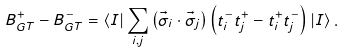<formula> <loc_0><loc_0><loc_500><loc_500>B _ { G T } ^ { + } - B _ { G T } ^ { - } = \left \langle I \right | \sum _ { i , j } \left ( \vec { \sigma } _ { i } \cdot \vec { \sigma } _ { j } \right ) \left ( t _ { i } ^ { - } t _ { j } ^ { + } - t _ { i } ^ { + } t _ { j } ^ { - } \right ) \left | I \right \rangle .</formula> 